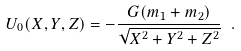Convert formula to latex. <formula><loc_0><loc_0><loc_500><loc_500>U _ { 0 } ( X , Y , Z ) = - \frac { G ( { m _ { 1 } } + { m _ { 2 } } ) } { \sqrt { X ^ { 2 } + Y ^ { 2 } + Z ^ { 2 } } } \ .</formula> 